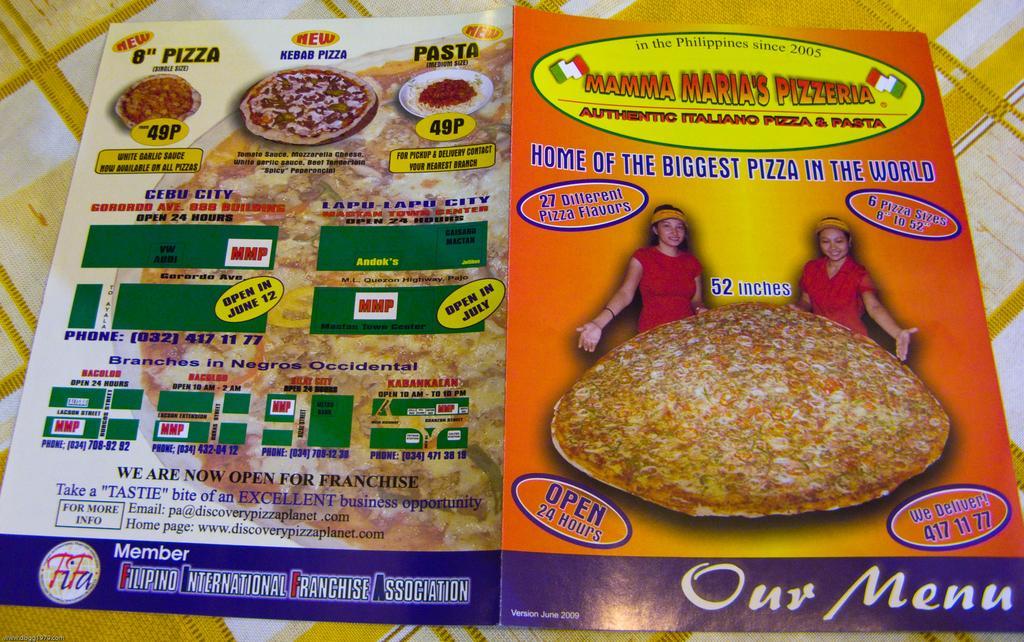Please provide a concise description of this image. In this image two posters are on the cloth. Right side poster is having images of two persons. Before them there is a pizza. Left side poster is having images of pizzas and some text on it. 